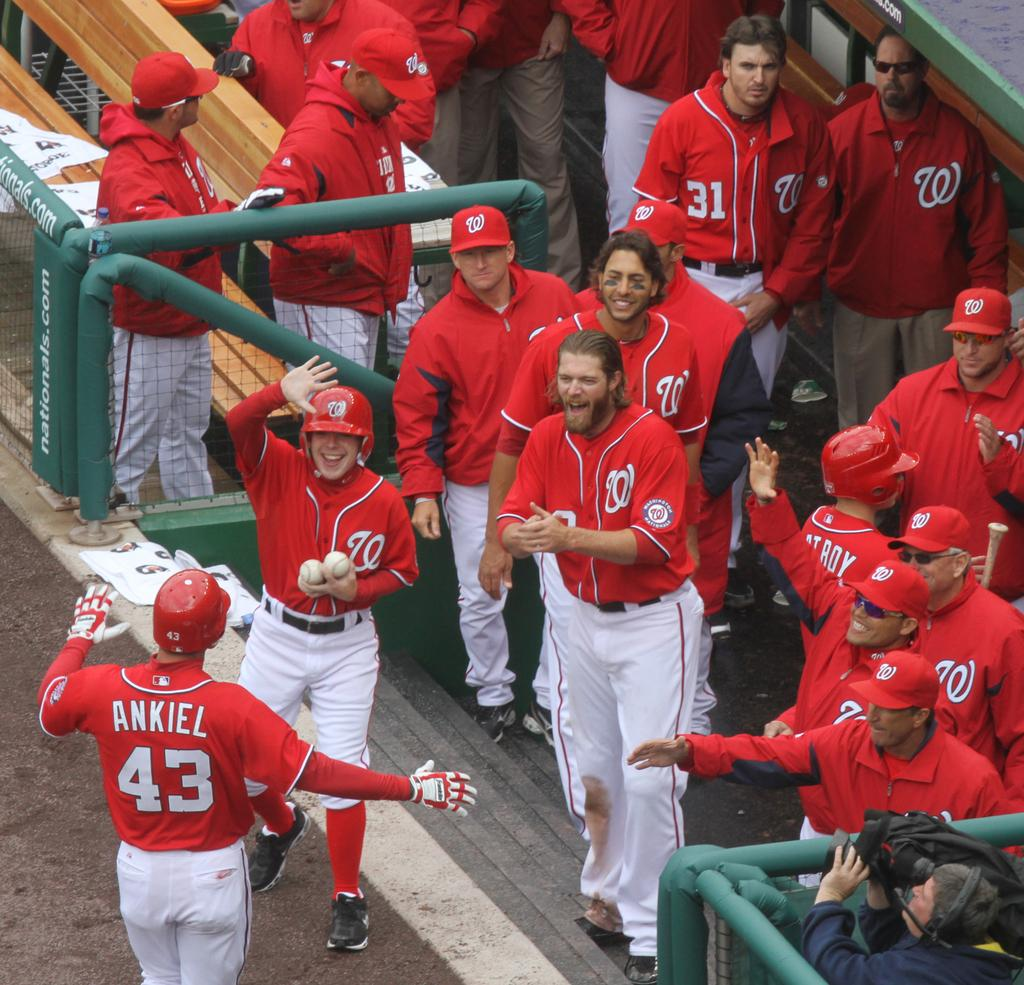<image>
Give a short and clear explanation of the subsequent image. A baseball team giving a high five to a player named Ankiel as he walks towards the dug out. 